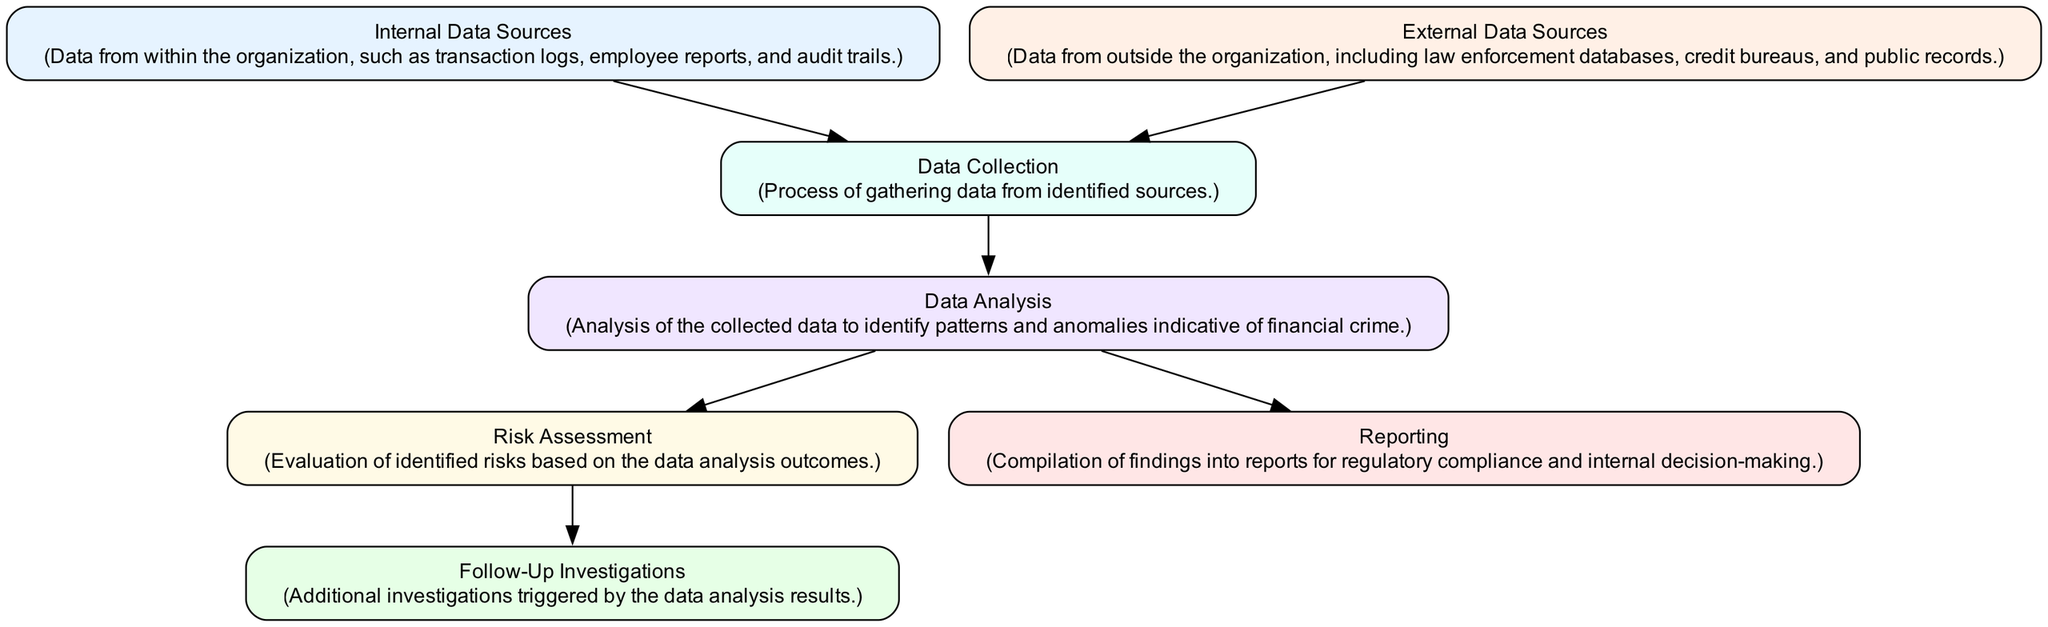What are the internal data sources? The internal data sources are data from within the organization, such as transaction logs, employee reports, and audit trails. This information is taken directly from the node labeled "Internal Data Sources" in the diagram.
Answer: Internal Data Sources How many nodes are in the diagram? By counting each distinct node represented in the diagram, we discover that there are seven nodes total. Each node corresponds to a different stage in the data flow, and they contribute to the overall process structure.
Answer: 7 What is the next step after Data Collection? The next step after Data Collection, indicated by the edge leading from Data Collection to Data Analysis, is Data Analysis. This flow connection shows how the collected data is processed for further investigation.
Answer: Data Analysis Which nodes directly lead to Follow-Up Investigations? The only node that directly leads to Follow-Up Investigations, based on the diagram's flow, is Risk Assessment. This shows that follow-up actions rely on the evaluations made regarding risks identified in the analysis step.
Answer: Risk Assessment What is the purpose of Data Analysis? The purpose of Data Analysis is to analyze the collected data to identify patterns and anomalies indicative of financial crime. This is specifically mentioned in the node description labeled "Data Analysis."
Answer: Identify patterns and anomalies What sources contribute to Data Collection? Both Internal Data Sources and External Data Sources contribute to Data Collection. The diagram shows two edges leading into Data Collection from these respective nodes, indicating they are both necessary inputs for gathering data.
Answer: Internal and External Data Sources How many edges connect the nodes in the diagram? By reviewing the connections between the nodes as represented in the diagram, we find that there are six edges connecting the nodes. Each edge represents a directional flow of data between different stages of the investigation process.
Answer: 6 What is the final output of the data flow process? The final output of the data flow process is Reporting. The flow comes from both Risk Assessment and Data Analysis, culminating in the compilation of findings into reports for compliance and decision-making.
Answer: Reporting 